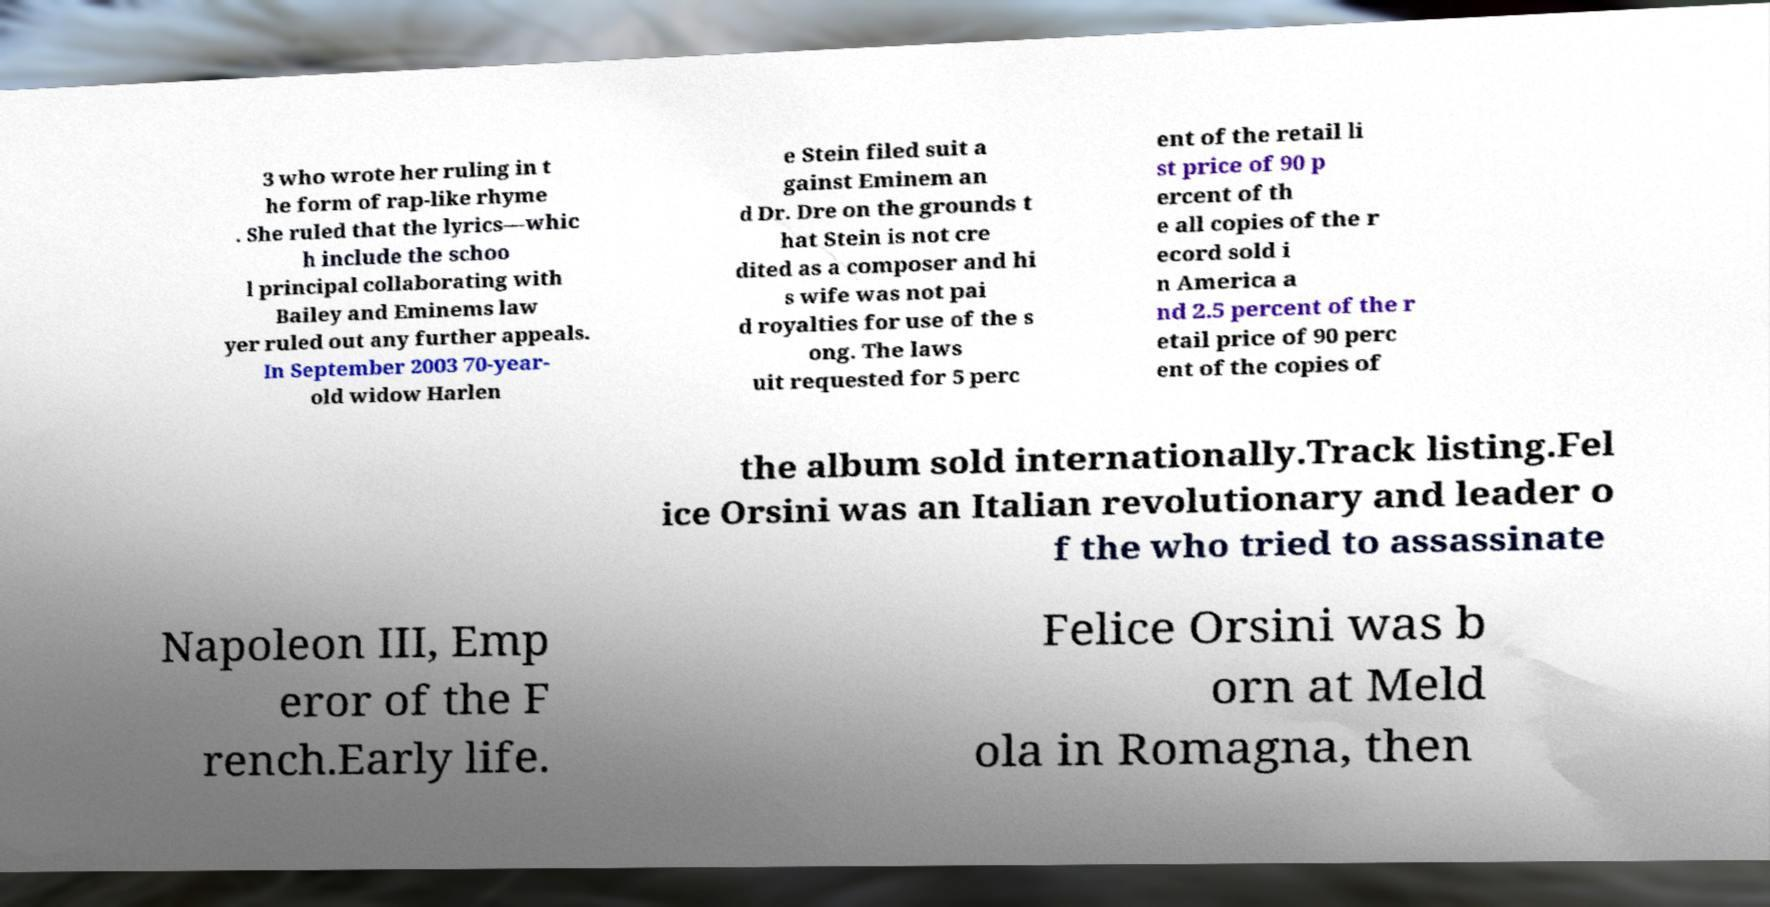Please read and relay the text visible in this image. What does it say? 3 who wrote her ruling in t he form of rap-like rhyme . She ruled that the lyrics—whic h include the schoo l principal collaborating with Bailey and Eminems law yer ruled out any further appeals. In September 2003 70-year- old widow Harlen e Stein filed suit a gainst Eminem an d Dr. Dre on the grounds t hat Stein is not cre dited as a composer and hi s wife was not pai d royalties for use of the s ong. The laws uit requested for 5 perc ent of the retail li st price of 90 p ercent of th e all copies of the r ecord sold i n America a nd 2.5 percent of the r etail price of 90 perc ent of the copies of the album sold internationally.Track listing.Fel ice Orsini was an Italian revolutionary and leader o f the who tried to assassinate Napoleon III, Emp eror of the F rench.Early life. Felice Orsini was b orn at Meld ola in Romagna, then 